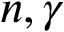<formula> <loc_0><loc_0><loc_500><loc_500>n , \gamma</formula> 